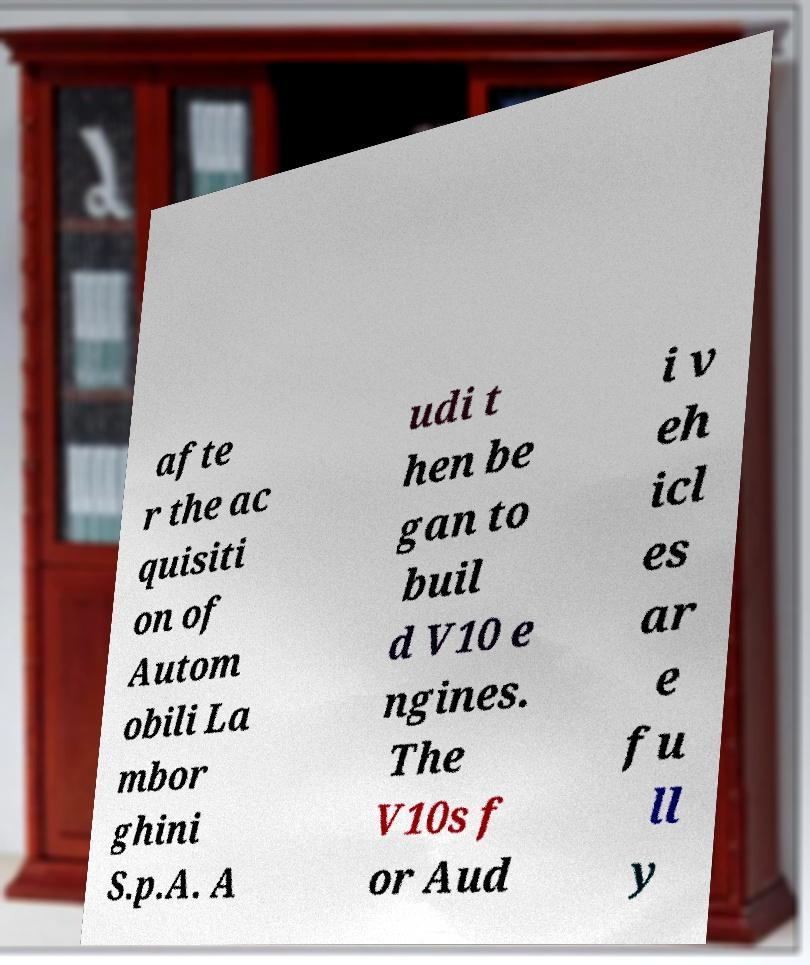For documentation purposes, I need the text within this image transcribed. Could you provide that? afte r the ac quisiti on of Autom obili La mbor ghini S.p.A. A udi t hen be gan to buil d V10 e ngines. The V10s f or Aud i v eh icl es ar e fu ll y 